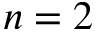<formula> <loc_0><loc_0><loc_500><loc_500>n = 2</formula> 